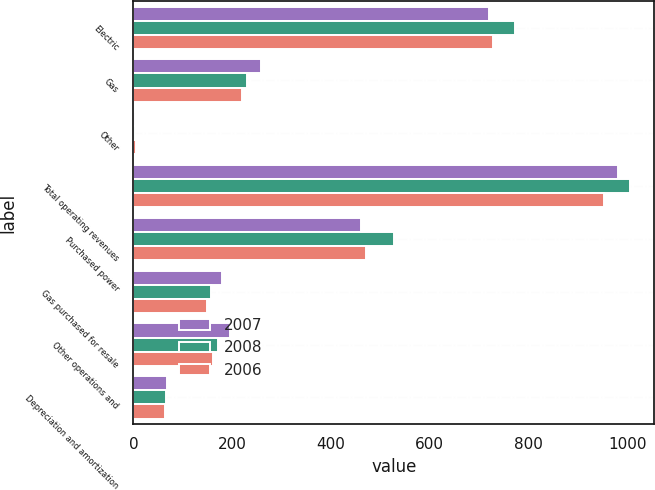Convert chart to OTSL. <chart><loc_0><loc_0><loc_500><loc_500><stacked_bar_chart><ecel><fcel>Electric<fcel>Gas<fcel>Other<fcel>Total operating revenues<fcel>Purchased power<fcel>Gas purchased for resale<fcel>Other operations and<fcel>Depreciation and amortization<nl><fcel>2007<fcel>720<fcel>259<fcel>3<fcel>982<fcel>461<fcel>179<fcel>196<fcel>67<nl><fcel>2008<fcel>772<fcel>230<fcel>3<fcel>1005<fcel>527<fcel>157<fcel>172<fcel>66<nl><fcel>2006<fcel>728<fcel>220<fcel>6<fcel>954<fcel>471<fcel>149<fcel>161<fcel>63<nl></chart> 